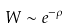<formula> <loc_0><loc_0><loc_500><loc_500>W \sim e ^ { - \rho }</formula> 